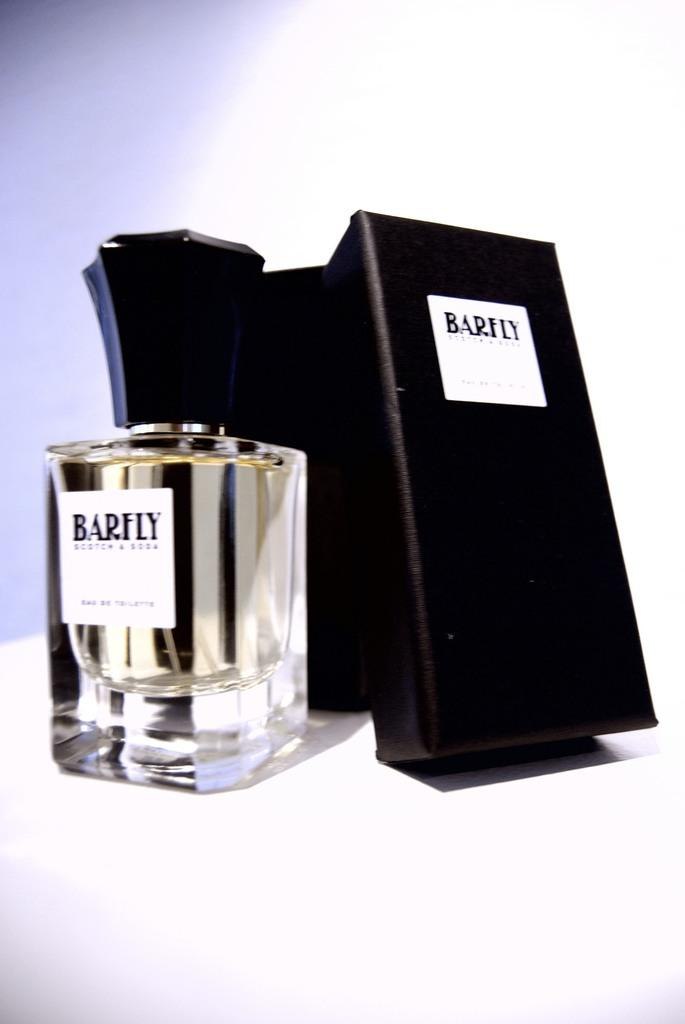<image>
Provide a brief description of the given image. A display box and glass bottle for Barfly Scotch and Soda 